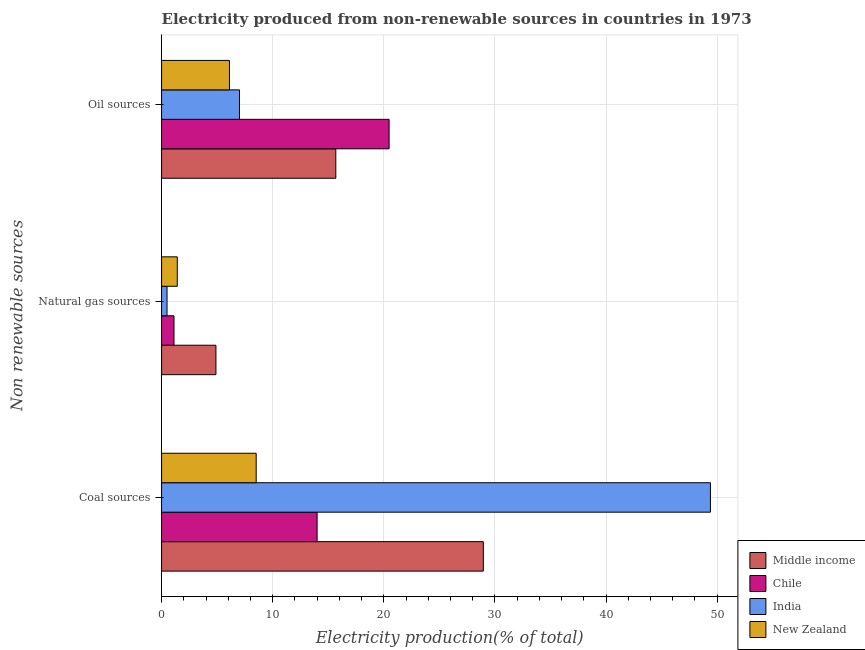How many groups of bars are there?
Make the answer very short. 3. Are the number of bars per tick equal to the number of legend labels?
Your answer should be compact. Yes. How many bars are there on the 1st tick from the top?
Your answer should be very brief. 4. What is the label of the 3rd group of bars from the top?
Ensure brevity in your answer.  Coal sources. What is the percentage of electricity produced by natural gas in New Zealand?
Give a very brief answer. 1.41. Across all countries, what is the maximum percentage of electricity produced by coal?
Make the answer very short. 49.4. Across all countries, what is the minimum percentage of electricity produced by coal?
Your response must be concise. 8.52. In which country was the percentage of electricity produced by natural gas maximum?
Offer a terse response. Middle income. In which country was the percentage of electricity produced by oil sources minimum?
Your answer should be very brief. New Zealand. What is the total percentage of electricity produced by coal in the graph?
Ensure brevity in your answer.  100.86. What is the difference between the percentage of electricity produced by coal in India and that in New Zealand?
Your response must be concise. 40.88. What is the difference between the percentage of electricity produced by oil sources in Chile and the percentage of electricity produced by natural gas in New Zealand?
Offer a very short reply. 19.06. What is the average percentage of electricity produced by coal per country?
Give a very brief answer. 25.22. What is the difference between the percentage of electricity produced by coal and percentage of electricity produced by oil sources in Chile?
Offer a terse response. -6.48. In how many countries, is the percentage of electricity produced by natural gas greater than 48 %?
Provide a succinct answer. 0. What is the ratio of the percentage of electricity produced by natural gas in Chile to that in India?
Your answer should be very brief. 2.27. Is the difference between the percentage of electricity produced by oil sources in New Zealand and Chile greater than the difference between the percentage of electricity produced by natural gas in New Zealand and Chile?
Give a very brief answer. No. What is the difference between the highest and the second highest percentage of electricity produced by natural gas?
Your answer should be very brief. 3.48. What is the difference between the highest and the lowest percentage of electricity produced by natural gas?
Ensure brevity in your answer.  4.4. What does the 2nd bar from the top in Natural gas sources represents?
Offer a very short reply. India. What does the 2nd bar from the bottom in Coal sources represents?
Provide a short and direct response. Chile. How many bars are there?
Make the answer very short. 12. How many countries are there in the graph?
Give a very brief answer. 4. Are the values on the major ticks of X-axis written in scientific E-notation?
Provide a short and direct response. No. Does the graph contain any zero values?
Your answer should be compact. No. How many legend labels are there?
Ensure brevity in your answer.  4. What is the title of the graph?
Ensure brevity in your answer.  Electricity produced from non-renewable sources in countries in 1973. What is the label or title of the X-axis?
Provide a succinct answer. Electricity production(% of total). What is the label or title of the Y-axis?
Make the answer very short. Non renewable sources. What is the Electricity production(% of total) in Middle income in Coal sources?
Provide a succinct answer. 28.96. What is the Electricity production(% of total) of Chile in Coal sources?
Ensure brevity in your answer.  14. What is the Electricity production(% of total) in India in Coal sources?
Your response must be concise. 49.4. What is the Electricity production(% of total) of New Zealand in Coal sources?
Provide a succinct answer. 8.52. What is the Electricity production(% of total) in Middle income in Natural gas sources?
Your answer should be compact. 4.89. What is the Electricity production(% of total) of Chile in Natural gas sources?
Keep it short and to the point. 1.12. What is the Electricity production(% of total) of India in Natural gas sources?
Offer a very short reply. 0.49. What is the Electricity production(% of total) in New Zealand in Natural gas sources?
Your answer should be very brief. 1.41. What is the Electricity production(% of total) of Middle income in Oil sources?
Provide a short and direct response. 15.68. What is the Electricity production(% of total) of Chile in Oil sources?
Give a very brief answer. 20.48. What is the Electricity production(% of total) of India in Oil sources?
Your answer should be very brief. 7.01. What is the Electricity production(% of total) of New Zealand in Oil sources?
Provide a short and direct response. 6.11. Across all Non renewable sources, what is the maximum Electricity production(% of total) of Middle income?
Your answer should be very brief. 28.96. Across all Non renewable sources, what is the maximum Electricity production(% of total) of Chile?
Offer a terse response. 20.48. Across all Non renewable sources, what is the maximum Electricity production(% of total) of India?
Ensure brevity in your answer.  49.4. Across all Non renewable sources, what is the maximum Electricity production(% of total) of New Zealand?
Your answer should be very brief. 8.52. Across all Non renewable sources, what is the minimum Electricity production(% of total) in Middle income?
Your answer should be very brief. 4.89. Across all Non renewable sources, what is the minimum Electricity production(% of total) of Chile?
Your answer should be very brief. 1.12. Across all Non renewable sources, what is the minimum Electricity production(% of total) of India?
Keep it short and to the point. 0.49. Across all Non renewable sources, what is the minimum Electricity production(% of total) of New Zealand?
Keep it short and to the point. 1.41. What is the total Electricity production(% of total) in Middle income in the graph?
Provide a short and direct response. 49.53. What is the total Electricity production(% of total) of Chile in the graph?
Offer a very short reply. 35.59. What is the total Electricity production(% of total) of India in the graph?
Keep it short and to the point. 56.9. What is the total Electricity production(% of total) in New Zealand in the graph?
Your answer should be very brief. 16.04. What is the difference between the Electricity production(% of total) of Middle income in Coal sources and that in Natural gas sources?
Provide a short and direct response. 24.06. What is the difference between the Electricity production(% of total) in Chile in Coal sources and that in Natural gas sources?
Ensure brevity in your answer.  12.88. What is the difference between the Electricity production(% of total) of India in Coal sources and that in Natural gas sources?
Offer a very short reply. 48.9. What is the difference between the Electricity production(% of total) in New Zealand in Coal sources and that in Natural gas sources?
Keep it short and to the point. 7.1. What is the difference between the Electricity production(% of total) of Middle income in Coal sources and that in Oil sources?
Keep it short and to the point. 13.28. What is the difference between the Electricity production(% of total) in Chile in Coal sources and that in Oil sources?
Your answer should be compact. -6.48. What is the difference between the Electricity production(% of total) of India in Coal sources and that in Oil sources?
Your answer should be compact. 42.38. What is the difference between the Electricity production(% of total) in New Zealand in Coal sources and that in Oil sources?
Offer a very short reply. 2.41. What is the difference between the Electricity production(% of total) in Middle income in Natural gas sources and that in Oil sources?
Your answer should be compact. -10.79. What is the difference between the Electricity production(% of total) of Chile in Natural gas sources and that in Oil sources?
Offer a terse response. -19.36. What is the difference between the Electricity production(% of total) of India in Natural gas sources and that in Oil sources?
Provide a succinct answer. -6.52. What is the difference between the Electricity production(% of total) in New Zealand in Natural gas sources and that in Oil sources?
Keep it short and to the point. -4.69. What is the difference between the Electricity production(% of total) in Middle income in Coal sources and the Electricity production(% of total) in Chile in Natural gas sources?
Ensure brevity in your answer.  27.84. What is the difference between the Electricity production(% of total) in Middle income in Coal sources and the Electricity production(% of total) in India in Natural gas sources?
Offer a very short reply. 28.46. What is the difference between the Electricity production(% of total) in Middle income in Coal sources and the Electricity production(% of total) in New Zealand in Natural gas sources?
Ensure brevity in your answer.  27.54. What is the difference between the Electricity production(% of total) in Chile in Coal sources and the Electricity production(% of total) in India in Natural gas sources?
Offer a terse response. 13.51. What is the difference between the Electricity production(% of total) in Chile in Coal sources and the Electricity production(% of total) in New Zealand in Natural gas sources?
Offer a very short reply. 12.58. What is the difference between the Electricity production(% of total) in India in Coal sources and the Electricity production(% of total) in New Zealand in Natural gas sources?
Your response must be concise. 47.98. What is the difference between the Electricity production(% of total) in Middle income in Coal sources and the Electricity production(% of total) in Chile in Oil sources?
Give a very brief answer. 8.48. What is the difference between the Electricity production(% of total) in Middle income in Coal sources and the Electricity production(% of total) in India in Oil sources?
Offer a terse response. 21.94. What is the difference between the Electricity production(% of total) of Middle income in Coal sources and the Electricity production(% of total) of New Zealand in Oil sources?
Provide a short and direct response. 22.85. What is the difference between the Electricity production(% of total) in Chile in Coal sources and the Electricity production(% of total) in India in Oil sources?
Ensure brevity in your answer.  6.98. What is the difference between the Electricity production(% of total) in Chile in Coal sources and the Electricity production(% of total) in New Zealand in Oil sources?
Make the answer very short. 7.89. What is the difference between the Electricity production(% of total) in India in Coal sources and the Electricity production(% of total) in New Zealand in Oil sources?
Provide a succinct answer. 43.29. What is the difference between the Electricity production(% of total) in Middle income in Natural gas sources and the Electricity production(% of total) in Chile in Oil sources?
Your response must be concise. -15.58. What is the difference between the Electricity production(% of total) of Middle income in Natural gas sources and the Electricity production(% of total) of India in Oil sources?
Make the answer very short. -2.12. What is the difference between the Electricity production(% of total) of Middle income in Natural gas sources and the Electricity production(% of total) of New Zealand in Oil sources?
Offer a very short reply. -1.22. What is the difference between the Electricity production(% of total) in Chile in Natural gas sources and the Electricity production(% of total) in India in Oil sources?
Provide a short and direct response. -5.89. What is the difference between the Electricity production(% of total) in Chile in Natural gas sources and the Electricity production(% of total) in New Zealand in Oil sources?
Keep it short and to the point. -4.99. What is the difference between the Electricity production(% of total) of India in Natural gas sources and the Electricity production(% of total) of New Zealand in Oil sources?
Your response must be concise. -5.62. What is the average Electricity production(% of total) of Middle income per Non renewable sources?
Make the answer very short. 16.51. What is the average Electricity production(% of total) in Chile per Non renewable sources?
Give a very brief answer. 11.86. What is the average Electricity production(% of total) in India per Non renewable sources?
Keep it short and to the point. 18.97. What is the average Electricity production(% of total) of New Zealand per Non renewable sources?
Provide a succinct answer. 5.35. What is the difference between the Electricity production(% of total) of Middle income and Electricity production(% of total) of Chile in Coal sources?
Your answer should be very brief. 14.96. What is the difference between the Electricity production(% of total) of Middle income and Electricity production(% of total) of India in Coal sources?
Your response must be concise. -20.44. What is the difference between the Electricity production(% of total) in Middle income and Electricity production(% of total) in New Zealand in Coal sources?
Offer a terse response. 20.44. What is the difference between the Electricity production(% of total) in Chile and Electricity production(% of total) in India in Coal sources?
Offer a very short reply. -35.4. What is the difference between the Electricity production(% of total) in Chile and Electricity production(% of total) in New Zealand in Coal sources?
Offer a very short reply. 5.48. What is the difference between the Electricity production(% of total) in India and Electricity production(% of total) in New Zealand in Coal sources?
Your answer should be very brief. 40.88. What is the difference between the Electricity production(% of total) of Middle income and Electricity production(% of total) of Chile in Natural gas sources?
Make the answer very short. 3.77. What is the difference between the Electricity production(% of total) of Middle income and Electricity production(% of total) of India in Natural gas sources?
Your answer should be very brief. 4.4. What is the difference between the Electricity production(% of total) in Middle income and Electricity production(% of total) in New Zealand in Natural gas sources?
Keep it short and to the point. 3.48. What is the difference between the Electricity production(% of total) of Chile and Electricity production(% of total) of India in Natural gas sources?
Your answer should be very brief. 0.63. What is the difference between the Electricity production(% of total) of Chile and Electricity production(% of total) of New Zealand in Natural gas sources?
Ensure brevity in your answer.  -0.3. What is the difference between the Electricity production(% of total) of India and Electricity production(% of total) of New Zealand in Natural gas sources?
Your answer should be very brief. -0.92. What is the difference between the Electricity production(% of total) of Middle income and Electricity production(% of total) of Chile in Oil sources?
Your response must be concise. -4.8. What is the difference between the Electricity production(% of total) in Middle income and Electricity production(% of total) in India in Oil sources?
Keep it short and to the point. 8.67. What is the difference between the Electricity production(% of total) in Middle income and Electricity production(% of total) in New Zealand in Oil sources?
Provide a succinct answer. 9.57. What is the difference between the Electricity production(% of total) in Chile and Electricity production(% of total) in India in Oil sources?
Provide a short and direct response. 13.46. What is the difference between the Electricity production(% of total) of Chile and Electricity production(% of total) of New Zealand in Oil sources?
Keep it short and to the point. 14.37. What is the difference between the Electricity production(% of total) of India and Electricity production(% of total) of New Zealand in Oil sources?
Provide a succinct answer. 0.9. What is the ratio of the Electricity production(% of total) of Middle income in Coal sources to that in Natural gas sources?
Your response must be concise. 5.92. What is the ratio of the Electricity production(% of total) of Chile in Coal sources to that in Natural gas sources?
Your response must be concise. 12.52. What is the ratio of the Electricity production(% of total) of India in Coal sources to that in Natural gas sources?
Your answer should be very brief. 100.44. What is the ratio of the Electricity production(% of total) in New Zealand in Coal sources to that in Natural gas sources?
Keep it short and to the point. 6.02. What is the ratio of the Electricity production(% of total) of Middle income in Coal sources to that in Oil sources?
Provide a short and direct response. 1.85. What is the ratio of the Electricity production(% of total) of Chile in Coal sources to that in Oil sources?
Offer a terse response. 0.68. What is the ratio of the Electricity production(% of total) of India in Coal sources to that in Oil sources?
Offer a very short reply. 7.04. What is the ratio of the Electricity production(% of total) in New Zealand in Coal sources to that in Oil sources?
Provide a succinct answer. 1.39. What is the ratio of the Electricity production(% of total) of Middle income in Natural gas sources to that in Oil sources?
Keep it short and to the point. 0.31. What is the ratio of the Electricity production(% of total) in Chile in Natural gas sources to that in Oil sources?
Keep it short and to the point. 0.05. What is the ratio of the Electricity production(% of total) in India in Natural gas sources to that in Oil sources?
Provide a succinct answer. 0.07. What is the ratio of the Electricity production(% of total) of New Zealand in Natural gas sources to that in Oil sources?
Give a very brief answer. 0.23. What is the difference between the highest and the second highest Electricity production(% of total) of Middle income?
Ensure brevity in your answer.  13.28. What is the difference between the highest and the second highest Electricity production(% of total) of Chile?
Make the answer very short. 6.48. What is the difference between the highest and the second highest Electricity production(% of total) in India?
Make the answer very short. 42.38. What is the difference between the highest and the second highest Electricity production(% of total) in New Zealand?
Provide a succinct answer. 2.41. What is the difference between the highest and the lowest Electricity production(% of total) in Middle income?
Provide a short and direct response. 24.06. What is the difference between the highest and the lowest Electricity production(% of total) in Chile?
Provide a succinct answer. 19.36. What is the difference between the highest and the lowest Electricity production(% of total) of India?
Provide a short and direct response. 48.9. What is the difference between the highest and the lowest Electricity production(% of total) of New Zealand?
Provide a succinct answer. 7.1. 